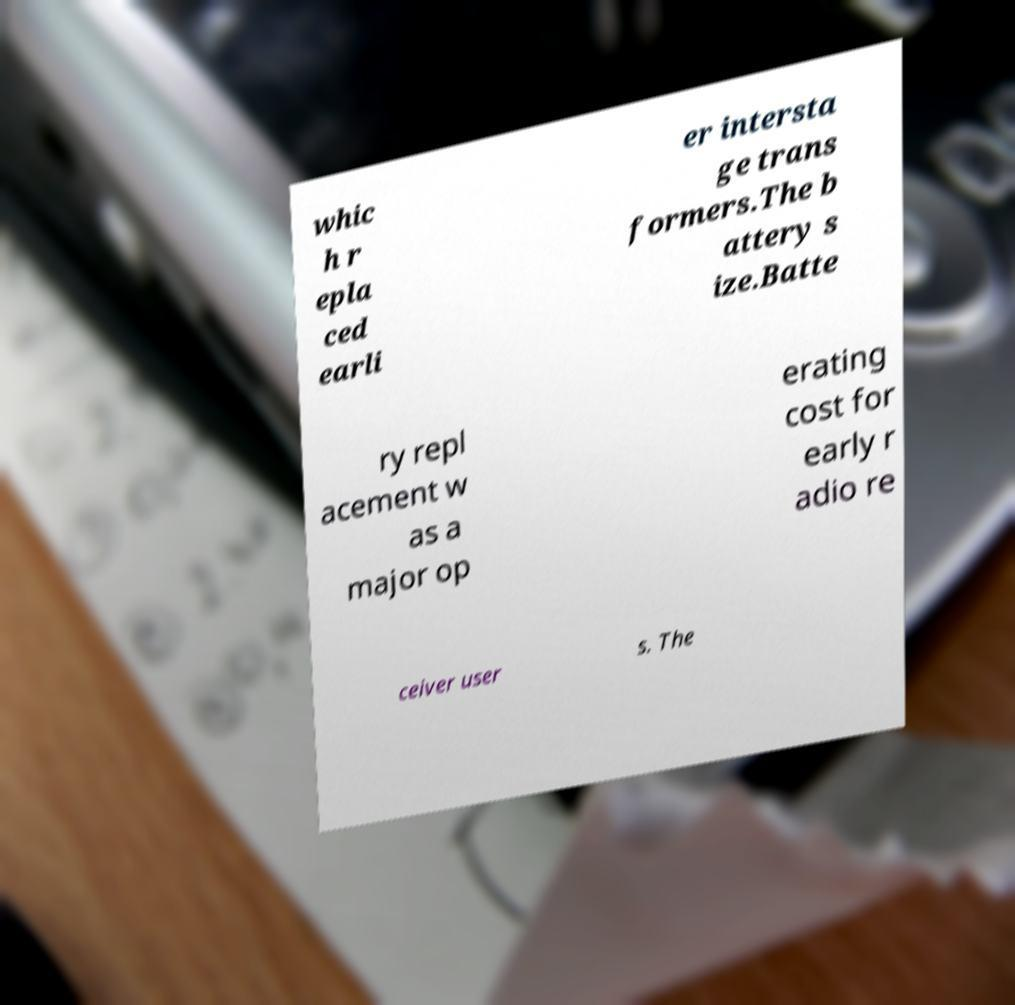Please identify and transcribe the text found in this image. whic h r epla ced earli er intersta ge trans formers.The b attery s ize.Batte ry repl acement w as a major op erating cost for early r adio re ceiver user s. The 